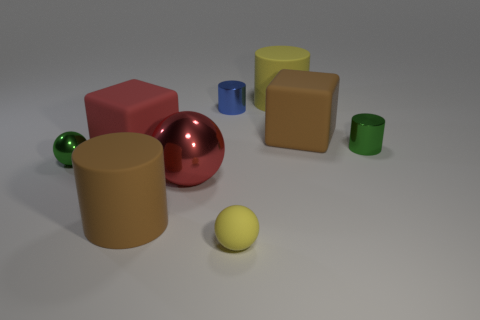Is the number of big things less than the number of large red balls?
Your answer should be compact. No. There is a red object that is the same size as the red ball; what is its shape?
Your answer should be very brief. Cube. What number of other things are there of the same color as the large sphere?
Provide a short and direct response. 1. How many tiny red blocks are there?
Ensure brevity in your answer.  0. How many brown objects are on the right side of the yellow cylinder and in front of the small green metal cylinder?
Offer a terse response. 0. What is the green ball made of?
Provide a short and direct response. Metal. Are there any rubber blocks?
Your answer should be very brief. Yes. What color is the matte cylinder behind the red shiny thing?
Your response must be concise. Yellow. There is a big yellow cylinder that is behind the large brown matte thing that is in front of the tiny green shiny cylinder; what number of large brown objects are right of it?
Your response must be concise. 1. There is a large thing that is both behind the red rubber thing and in front of the large yellow thing; what is its material?
Ensure brevity in your answer.  Rubber. 